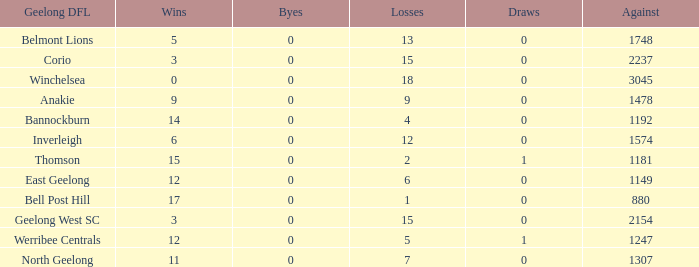What is the minimum number of victories when the byes are negative? None. 